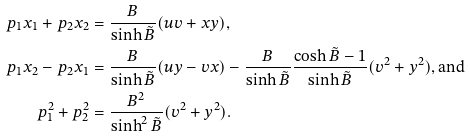<formula> <loc_0><loc_0><loc_500><loc_500>p _ { 1 } x _ { 1 } + p _ { 2 } x _ { 2 } & = \frac { B } { \sinh \tilde { B } } ( u v + x y ) , \\ p _ { 1 } x _ { 2 } - p _ { 2 } x _ { 1 } & = \frac { B } { \sinh \tilde { B } } ( u y - v x ) - \frac { B } { \sinh \tilde { B } } \frac { \cosh \tilde { B } - 1 } { \sinh \tilde { B } } ( v ^ { 2 } + y ^ { 2 } ) , \text {and} \\ p _ { 1 } ^ { 2 } + p _ { 2 } ^ { 2 } & = \frac { B ^ { 2 } } { \sinh ^ { 2 } \tilde { B } } ( v ^ { 2 } + y ^ { 2 } ) .</formula> 